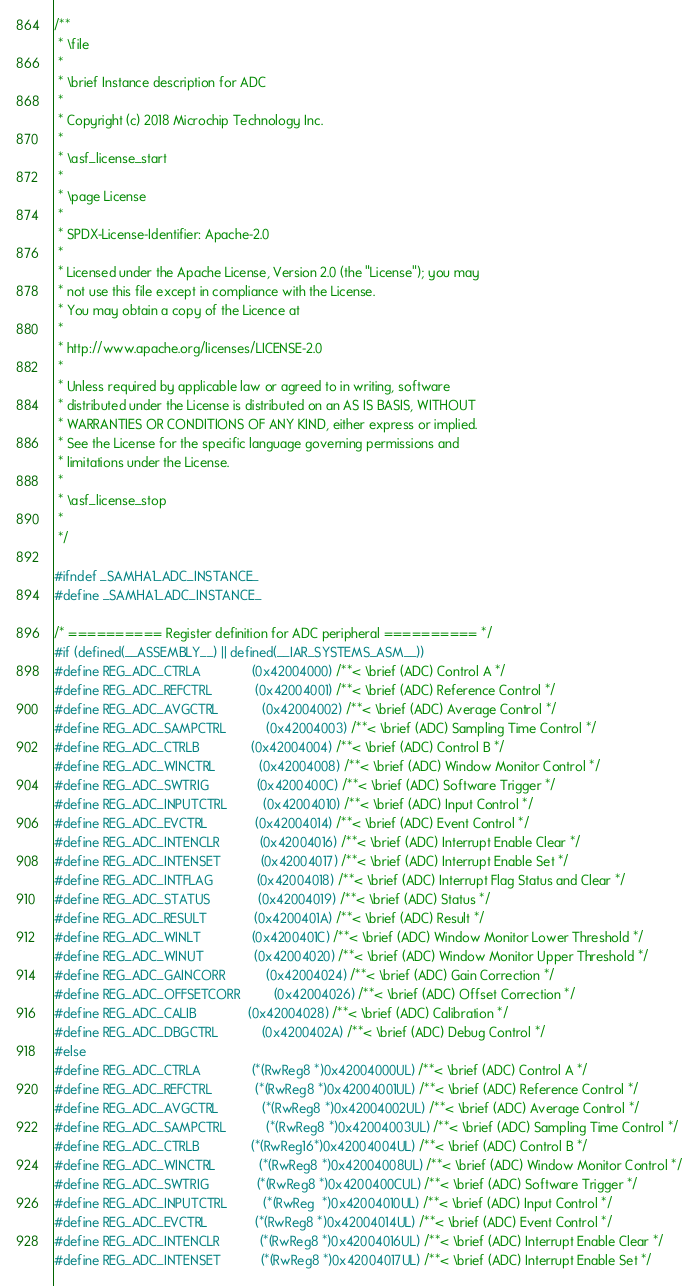<code> <loc_0><loc_0><loc_500><loc_500><_C_>/**
 * \file
 *
 * \brief Instance description for ADC
 *
 * Copyright (c) 2018 Microchip Technology Inc.
 *
 * \asf_license_start
 *
 * \page License
 *
 * SPDX-License-Identifier: Apache-2.0
 *
 * Licensed under the Apache License, Version 2.0 (the "License"); you may
 * not use this file except in compliance with the License.
 * You may obtain a copy of the Licence at
 * 
 * http://www.apache.org/licenses/LICENSE-2.0
 * 
 * Unless required by applicable law or agreed to in writing, software
 * distributed under the License is distributed on an AS IS BASIS, WITHOUT
 * WARRANTIES OR CONDITIONS OF ANY KIND, either express or implied.
 * See the License for the specific language governing permissions and
 * limitations under the License.
 *
 * \asf_license_stop
 *
 */

#ifndef _SAMHA1_ADC_INSTANCE_
#define _SAMHA1_ADC_INSTANCE_

/* ========== Register definition for ADC peripheral ========== */
#if (defined(__ASSEMBLY__) || defined(__IAR_SYSTEMS_ASM__))
#define REG_ADC_CTRLA              (0x42004000) /**< \brief (ADC) Control A */
#define REG_ADC_REFCTRL            (0x42004001) /**< \brief (ADC) Reference Control */
#define REG_ADC_AVGCTRL            (0x42004002) /**< \brief (ADC) Average Control */
#define REG_ADC_SAMPCTRL           (0x42004003) /**< \brief (ADC) Sampling Time Control */
#define REG_ADC_CTRLB              (0x42004004) /**< \brief (ADC) Control B */
#define REG_ADC_WINCTRL            (0x42004008) /**< \brief (ADC) Window Monitor Control */
#define REG_ADC_SWTRIG             (0x4200400C) /**< \brief (ADC) Software Trigger */
#define REG_ADC_INPUTCTRL          (0x42004010) /**< \brief (ADC) Input Control */
#define REG_ADC_EVCTRL             (0x42004014) /**< \brief (ADC) Event Control */
#define REG_ADC_INTENCLR           (0x42004016) /**< \brief (ADC) Interrupt Enable Clear */
#define REG_ADC_INTENSET           (0x42004017) /**< \brief (ADC) Interrupt Enable Set */
#define REG_ADC_INTFLAG            (0x42004018) /**< \brief (ADC) Interrupt Flag Status and Clear */
#define REG_ADC_STATUS             (0x42004019) /**< \brief (ADC) Status */
#define REG_ADC_RESULT             (0x4200401A) /**< \brief (ADC) Result */
#define REG_ADC_WINLT              (0x4200401C) /**< \brief (ADC) Window Monitor Lower Threshold */
#define REG_ADC_WINUT              (0x42004020) /**< \brief (ADC) Window Monitor Upper Threshold */
#define REG_ADC_GAINCORR           (0x42004024) /**< \brief (ADC) Gain Correction */
#define REG_ADC_OFFSETCORR         (0x42004026) /**< \brief (ADC) Offset Correction */
#define REG_ADC_CALIB              (0x42004028) /**< \brief (ADC) Calibration */
#define REG_ADC_DBGCTRL            (0x4200402A) /**< \brief (ADC) Debug Control */
#else
#define REG_ADC_CTRLA              (*(RwReg8 *)0x42004000UL) /**< \brief (ADC) Control A */
#define REG_ADC_REFCTRL            (*(RwReg8 *)0x42004001UL) /**< \brief (ADC) Reference Control */
#define REG_ADC_AVGCTRL            (*(RwReg8 *)0x42004002UL) /**< \brief (ADC) Average Control */
#define REG_ADC_SAMPCTRL           (*(RwReg8 *)0x42004003UL) /**< \brief (ADC) Sampling Time Control */
#define REG_ADC_CTRLB              (*(RwReg16*)0x42004004UL) /**< \brief (ADC) Control B */
#define REG_ADC_WINCTRL            (*(RwReg8 *)0x42004008UL) /**< \brief (ADC) Window Monitor Control */
#define REG_ADC_SWTRIG             (*(RwReg8 *)0x4200400CUL) /**< \brief (ADC) Software Trigger */
#define REG_ADC_INPUTCTRL          (*(RwReg  *)0x42004010UL) /**< \brief (ADC) Input Control */
#define REG_ADC_EVCTRL             (*(RwReg8 *)0x42004014UL) /**< \brief (ADC) Event Control */
#define REG_ADC_INTENCLR           (*(RwReg8 *)0x42004016UL) /**< \brief (ADC) Interrupt Enable Clear */
#define REG_ADC_INTENSET           (*(RwReg8 *)0x42004017UL) /**< \brief (ADC) Interrupt Enable Set */</code> 